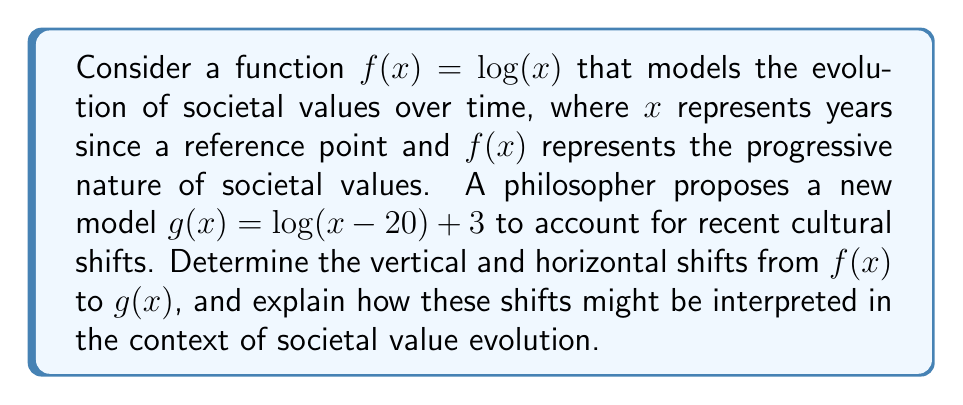Show me your answer to this math problem. To determine the vertical and horizontal shifts, let's analyze the transformation from $f(x)$ to $g(x)$:

1) First, let's identify the general form of a transformed logarithmic function:
   $g(x) = a \log(b(x-h)) + k$
   where $h$ represents the horizontal shift and $k$ represents the vertical shift.

2) Comparing our function $g(x) = \log(x-20) + 3$ to this general form, we can see that:
   $a = 1$ (no vertical stretch/compression)
   $b = 1$ (no horizontal stretch/compression)
   $h = 20$ (horizontal shift)
   $k = 3$ (vertical shift)

3) Horizontal shift: The term $(x-20)$ inside the logarithm indicates a right shift of 20 units.

4) Vertical shift: The $+3$ outside the logarithm indicates an upward shift of 3 units.

Interpretation:
- The horizontal shift of 20 units to the right could represent a 20-year delay in the onset of significant societal value changes compared to the original model.
- The vertical shift of 3 units upward might indicate that the new model assumes a generally more progressive baseline for societal values across all time periods.

This transformation suggests that while the philosopher believes societal progress may have started later than originally thought (horizontal shift), they also believe that society as a whole has become more progressive overall (vertical shift).
Answer: Right shift: 20 units; Upward shift: 3 units 